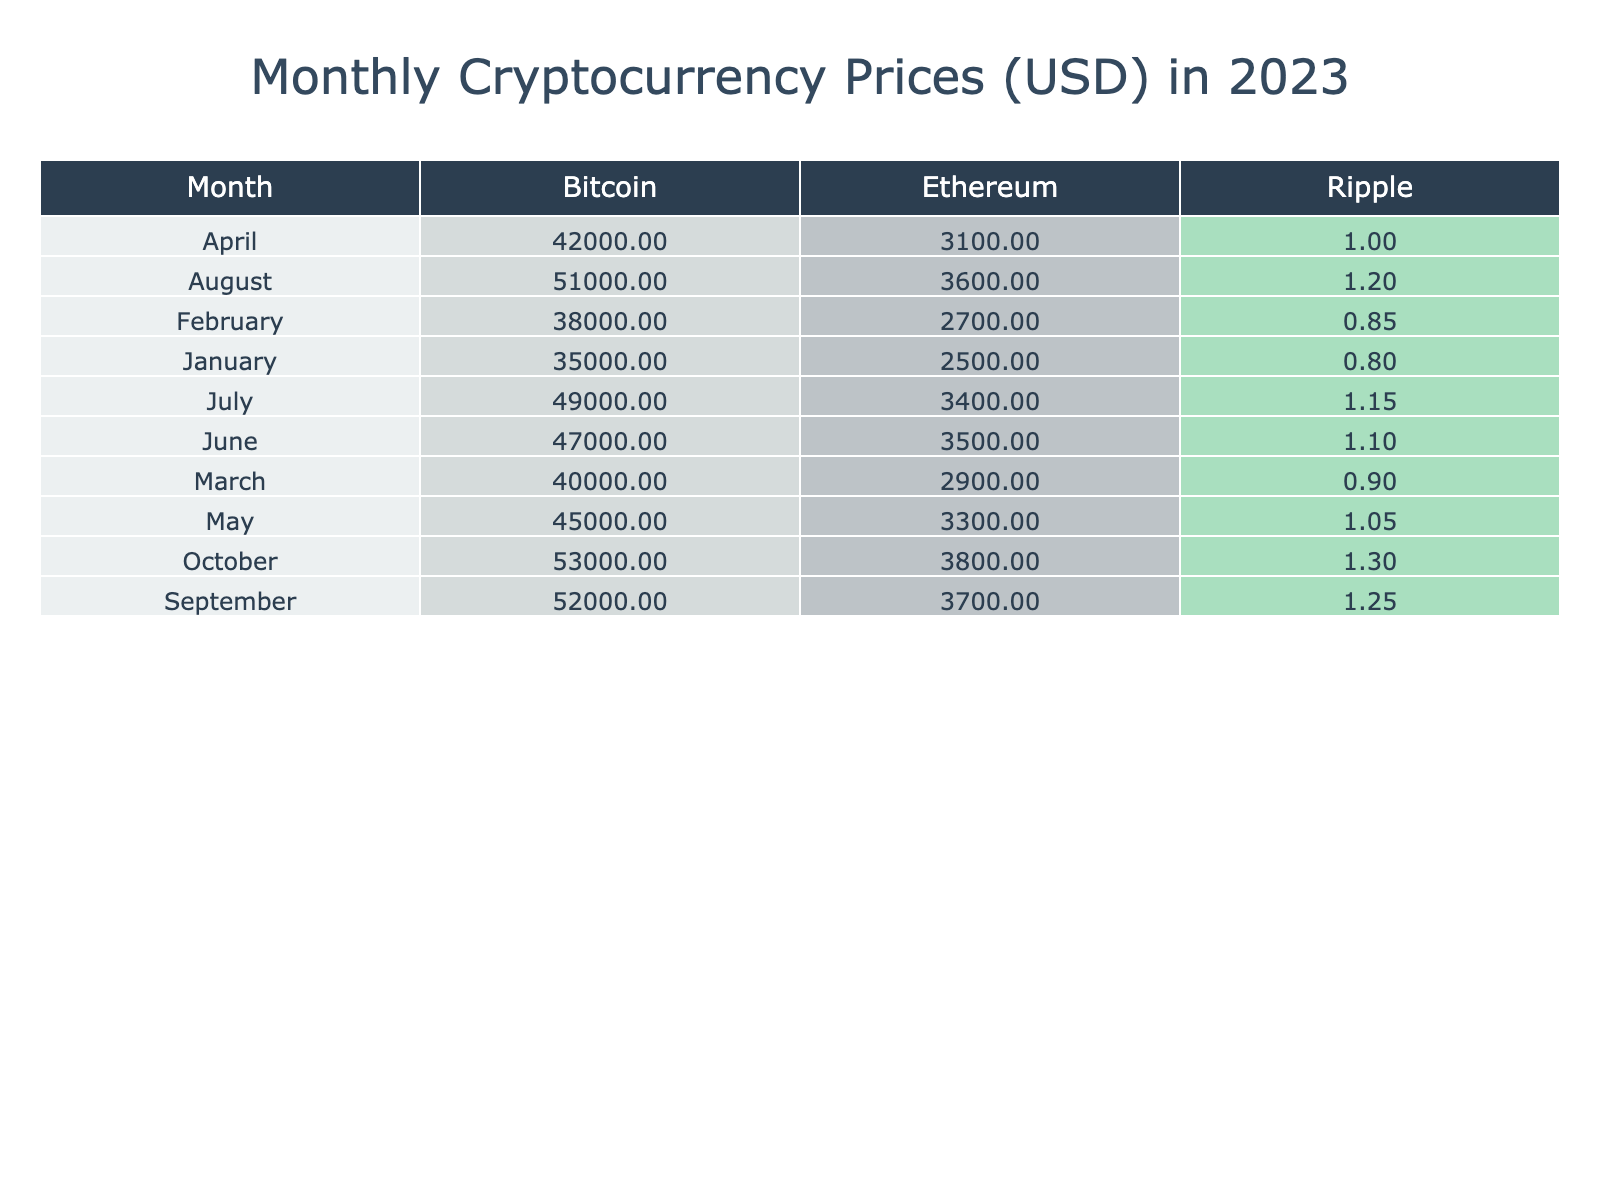What was the price of Bitcoin in April? From the table, we can locate the row for April and check the corresponding value for Bitcoin, which is 42000 USD.
Answer: 42000 USD Which month had the highest price for Ethereum? By inspecting the table, we see that Ethereum's highest price occurred in May at 3300 USD.
Answer: May What is the price change percentage of Ripple in February? The table shows that the price change percentage for Ripple in February is 6.3%.
Answer: 6.3% What was the average price of Bitcoin from January to June? To find the average, sum up the prices in the first six months: (35000 + 38000 + 40000 + 42000 + 45000 + 47000) = 227000. Then, divide by the number of months, which is 6: 227000 / 6 = 37833.33.
Answer: 37833.33 Did Ethereum have a higher price than Ripple in March? In March, Ethereum's price was 2900 USD while Ripple's was 0.90 USD, hence Ethereum had a higher price than Ripple.
Answer: Yes What was the maximum market cap of Ripple during 2023? After checking each month's market cap for Ripple in the table, the maximum was found to be 62 billion USD in September.
Answer: 62 billion USD How much did the trading volume of Bitcoin increase from March to April? From the table, Bitcoin's trading volume in March was 45 billion USD, and in April it increased to 50 billion USD. The increase is 50 - 45 = 5 billion USD.
Answer: 5 billion USD Which cryptocurrency had the least price increase percentage in July? Looking at the price change percentages for July: Bitcoin (4.3%), Ethereum (2.9%), and Ripple (4.5%). Ethereum had the least change at 2.9%.
Answer: Ethereum What was the combined price of Ripple in the first half of 2023? For the first half of the year, we add up Ripple's prices for January (0.80), February (0.85), March (0.90), April (1.00), May (1.05), and June (1.10), giving us a total of 0.80 + 0.85 + 0.90 + 1.00 + 1.05 + 1.10 = 5.70.
Answer: 5.70 